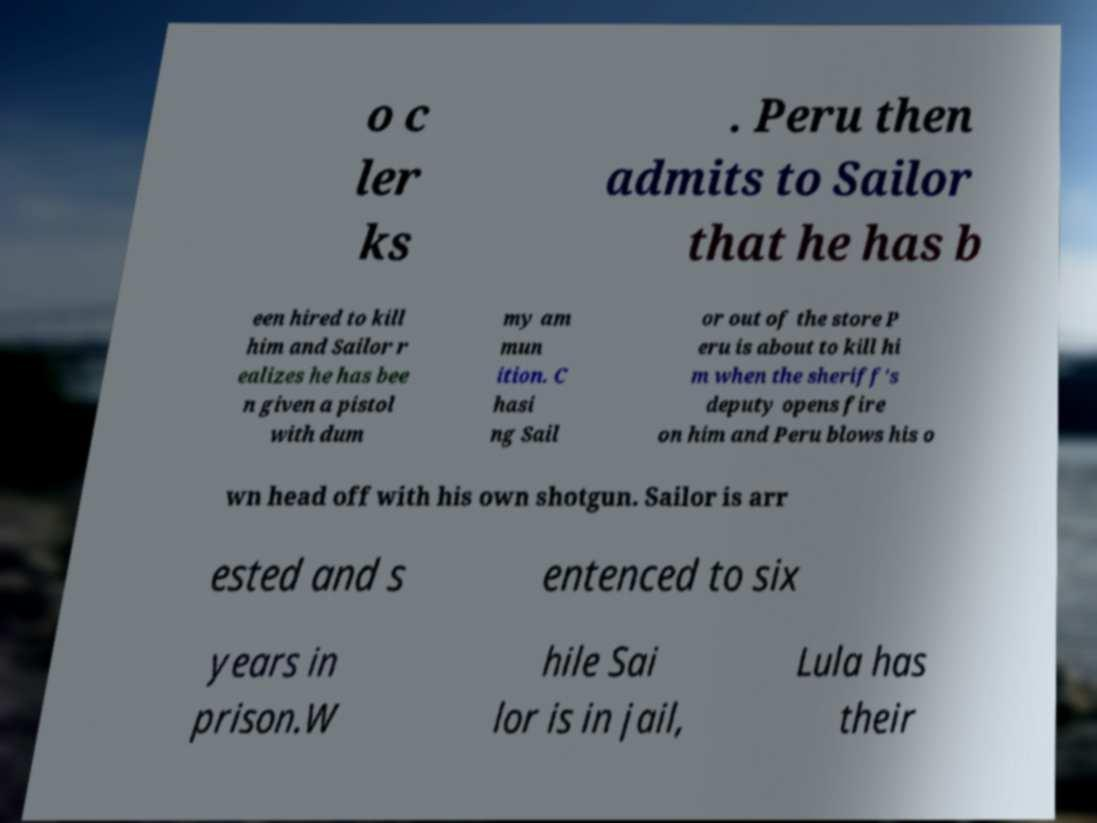Please identify and transcribe the text found in this image. o c ler ks . Peru then admits to Sailor that he has b een hired to kill him and Sailor r ealizes he has bee n given a pistol with dum my am mun ition. C hasi ng Sail or out of the store P eru is about to kill hi m when the sheriff's deputy opens fire on him and Peru blows his o wn head off with his own shotgun. Sailor is arr ested and s entenced to six years in prison.W hile Sai lor is in jail, Lula has their 